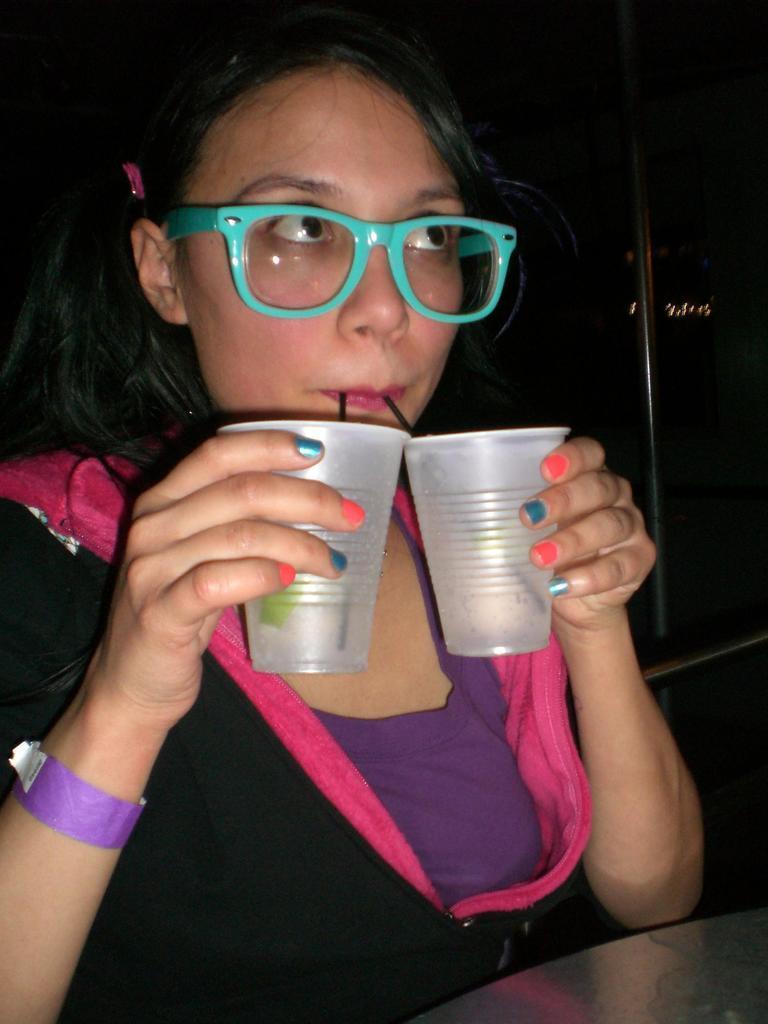Please provide a concise description of this image. In this image there is a girl holding two glasses in her hands and she is placing two straws in her mouth, in front of the girl there is a table. The background is dark. 